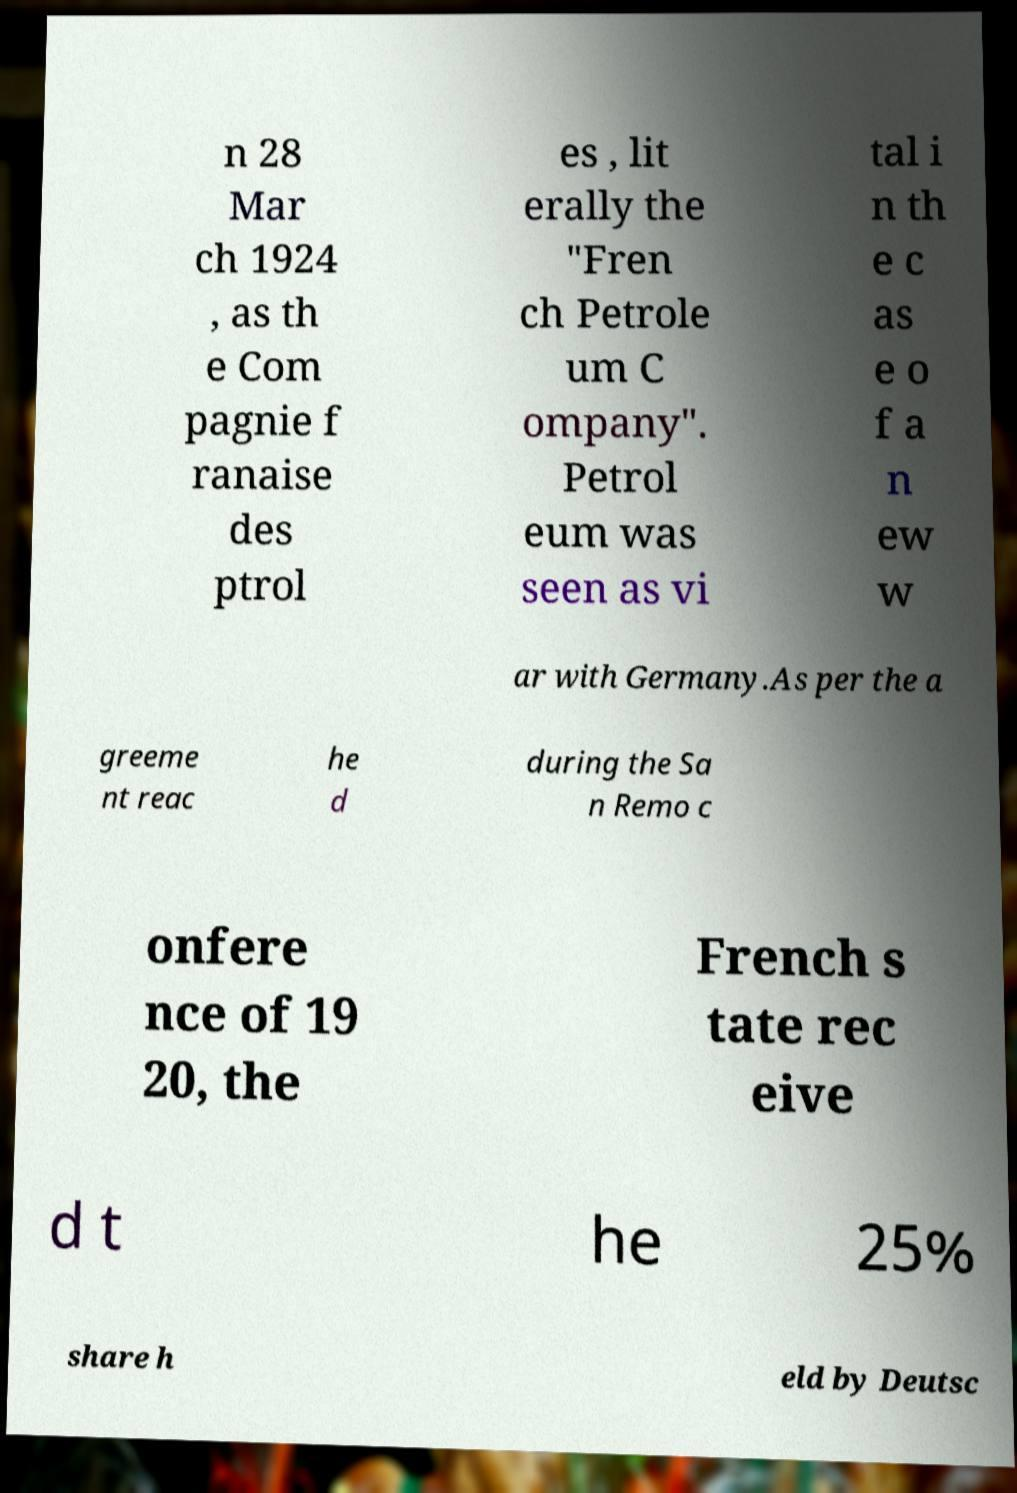I need the written content from this picture converted into text. Can you do that? n 28 Mar ch 1924 , as th e Com pagnie f ranaise des ptrol es , lit erally the "Fren ch Petrole um C ompany". Petrol eum was seen as vi tal i n th e c as e o f a n ew w ar with Germany.As per the a greeme nt reac he d during the Sa n Remo c onfere nce of 19 20, the French s tate rec eive d t he 25% share h eld by Deutsc 